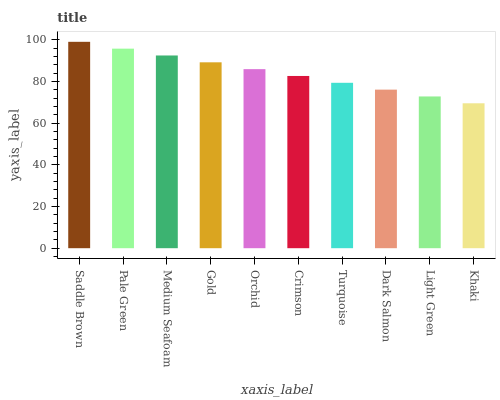Is Khaki the minimum?
Answer yes or no. Yes. Is Saddle Brown the maximum?
Answer yes or no. Yes. Is Pale Green the minimum?
Answer yes or no. No. Is Pale Green the maximum?
Answer yes or no. No. Is Saddle Brown greater than Pale Green?
Answer yes or no. Yes. Is Pale Green less than Saddle Brown?
Answer yes or no. Yes. Is Pale Green greater than Saddle Brown?
Answer yes or no. No. Is Saddle Brown less than Pale Green?
Answer yes or no. No. Is Orchid the high median?
Answer yes or no. Yes. Is Crimson the low median?
Answer yes or no. Yes. Is Saddle Brown the high median?
Answer yes or no. No. Is Turquoise the low median?
Answer yes or no. No. 